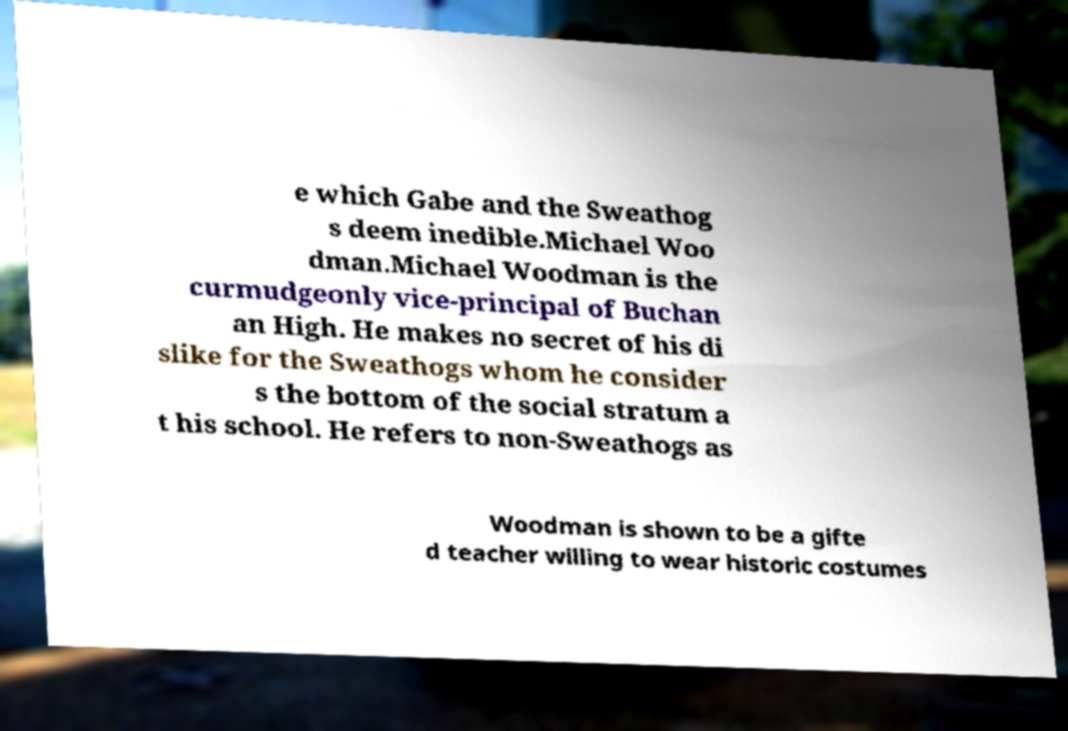Can you accurately transcribe the text from the provided image for me? e which Gabe and the Sweathog s deem inedible.Michael Woo dman.Michael Woodman is the curmudgeonly vice-principal of Buchan an High. He makes no secret of his di slike for the Sweathogs whom he consider s the bottom of the social stratum a t his school. He refers to non-Sweathogs as Woodman is shown to be a gifte d teacher willing to wear historic costumes 